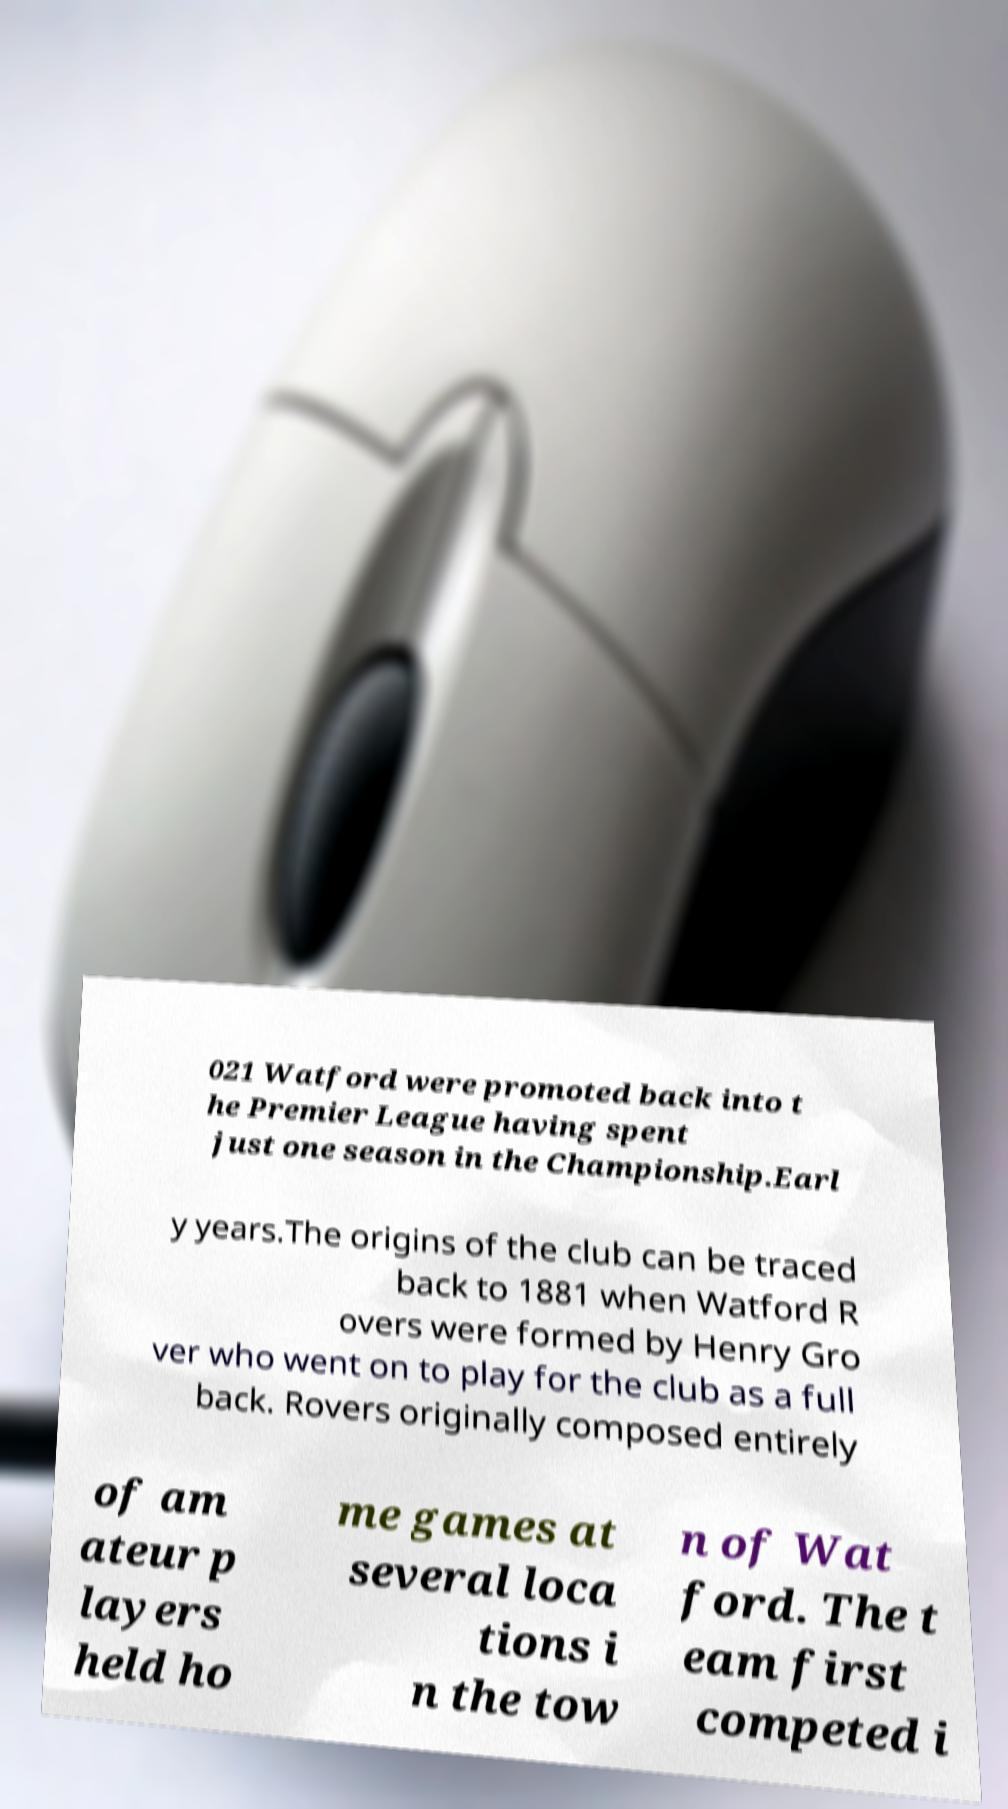I need the written content from this picture converted into text. Can you do that? 021 Watford were promoted back into t he Premier League having spent just one season in the Championship.Earl y years.The origins of the club can be traced back to 1881 when Watford R overs were formed by Henry Gro ver who went on to play for the club as a full back. Rovers originally composed entirely of am ateur p layers held ho me games at several loca tions i n the tow n of Wat ford. The t eam first competed i 